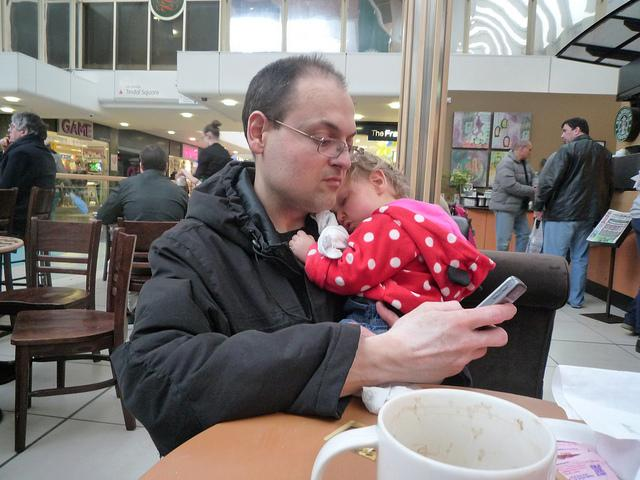Where is this man and child sitting? Please explain your reasoning. starbucks. The man and kid are at starbucks. 